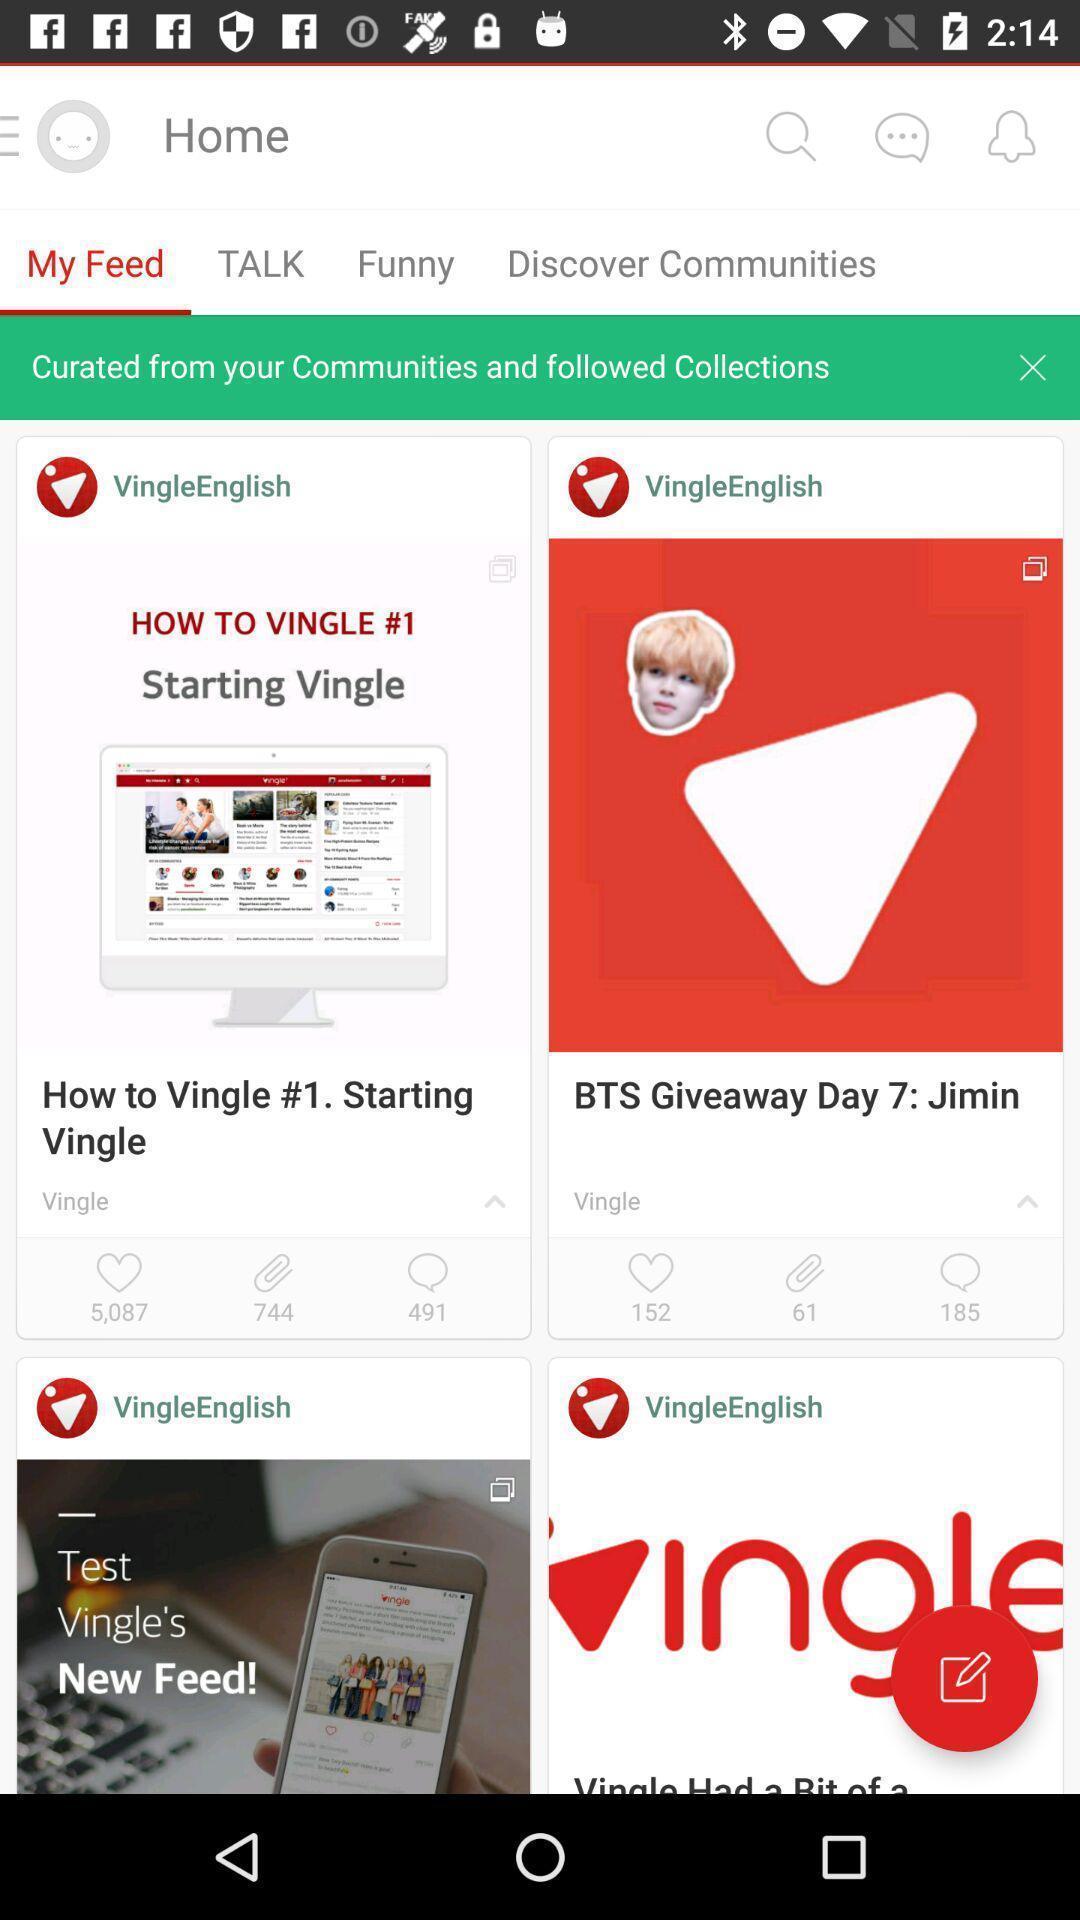What details can you identify in this image? Page displaying of my feed for social networking app. 